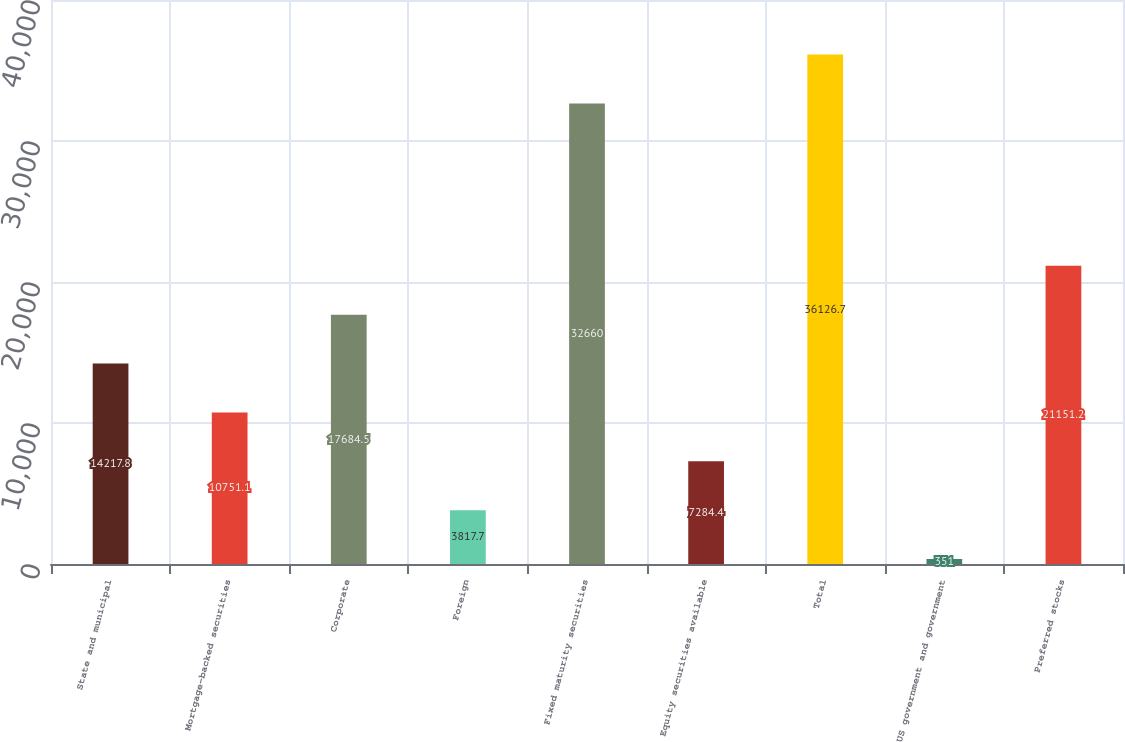Convert chart to OTSL. <chart><loc_0><loc_0><loc_500><loc_500><bar_chart><fcel>State and municipal<fcel>Mortgage-backed securities<fcel>Corporate<fcel>Foreign<fcel>Fixed maturity securities<fcel>Equity securities available<fcel>Total<fcel>US government and government<fcel>Preferred stocks<nl><fcel>14217.8<fcel>10751.1<fcel>17684.5<fcel>3817.7<fcel>32660<fcel>7284.4<fcel>36126.7<fcel>351<fcel>21151.2<nl></chart> 